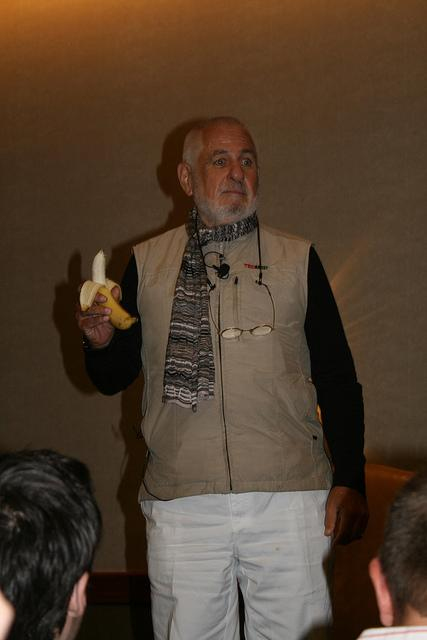What type of eyesight does the man standing here have? poor 